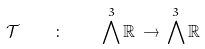<formula> <loc_0><loc_0><loc_500><loc_500>\mathcal { T } \quad \colon \quad \bigwedge ^ { 3 } \mathbb { R } \, \rightarrow \, \bigwedge ^ { 3 } \mathbb { R }</formula> 